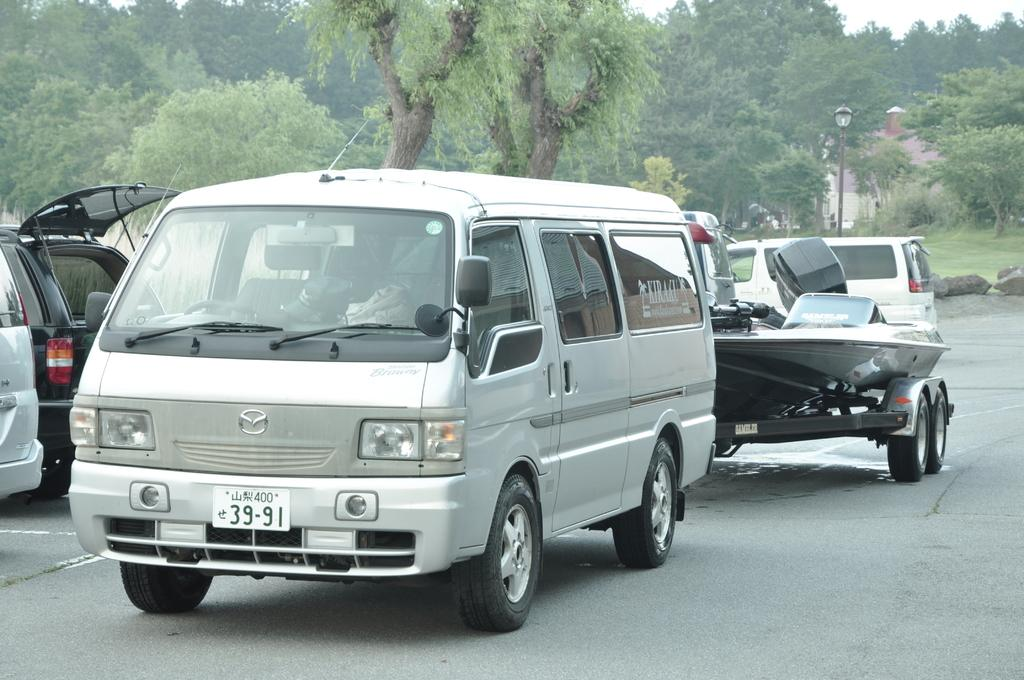<image>
Relay a brief, clear account of the picture shown. A white van with the license plate 39-91 is pulling a boat. 